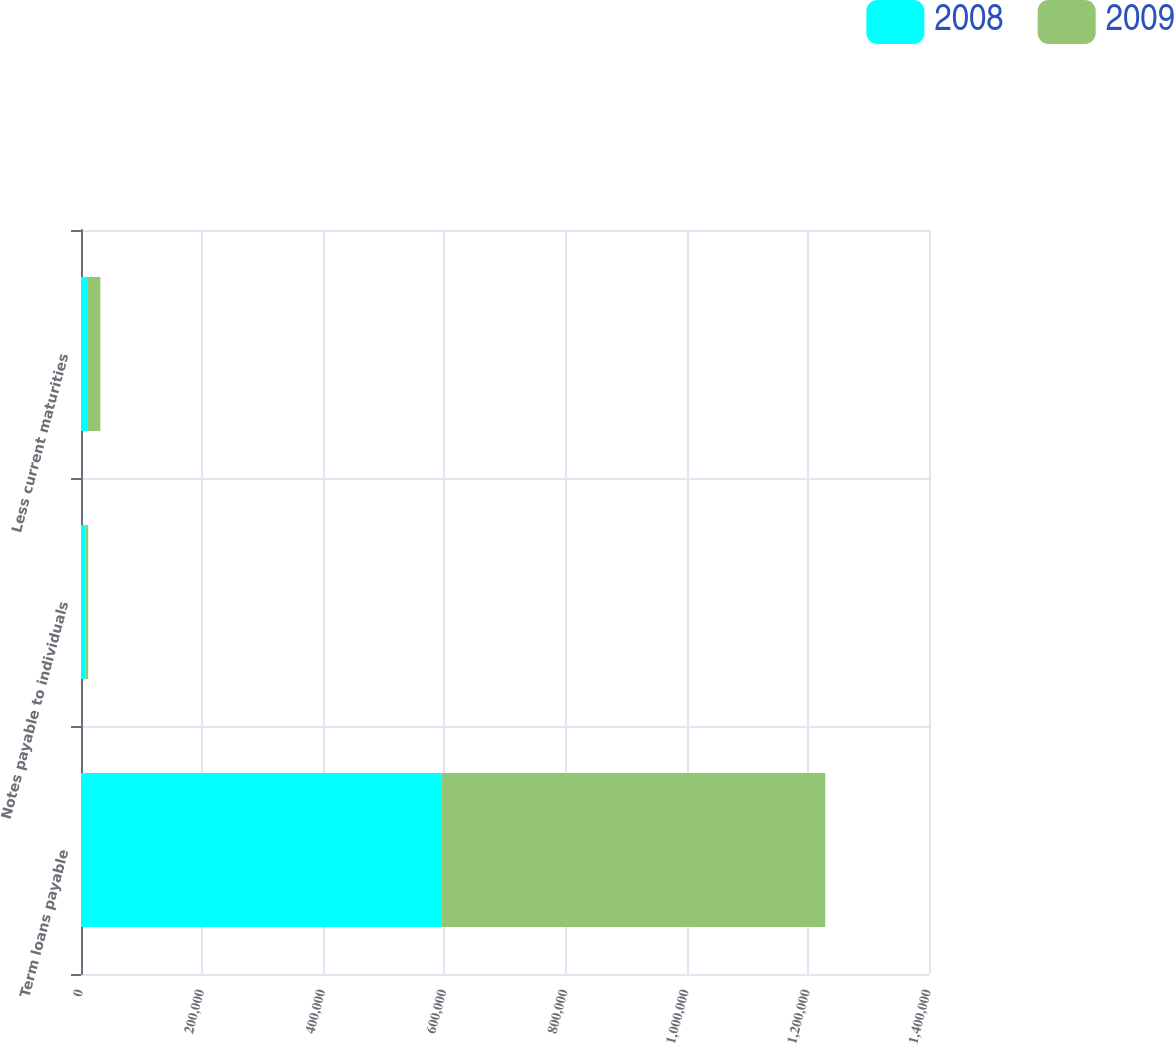Convert chart to OTSL. <chart><loc_0><loc_0><loc_500><loc_500><stacked_bar_chart><ecel><fcel>Term loans payable<fcel>Notes payable to individuals<fcel>Less current maturities<nl><fcel>2008<fcel>595716<fcel>7329<fcel>10063<nl><fcel>2009<fcel>632983<fcel>4549<fcel>21934<nl></chart> 